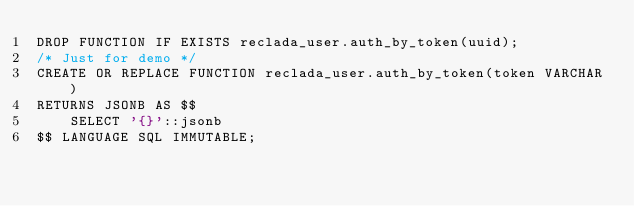Convert code to text. <code><loc_0><loc_0><loc_500><loc_500><_SQL_>DROP FUNCTION IF EXISTS reclada_user.auth_by_token(uuid);
/* Just for demo */
CREATE OR REPLACE FUNCTION reclada_user.auth_by_token(token VARCHAR)
RETURNS JSONB AS $$
    SELECT '{}'::jsonb
$$ LANGUAGE SQL IMMUTABLE;</code> 